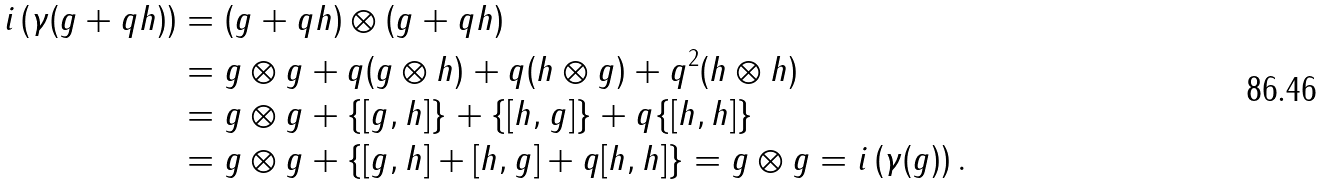Convert formula to latex. <formula><loc_0><loc_0><loc_500><loc_500>i \left ( \gamma ( g + q h ) \right ) & = ( g + q h ) \otimes ( g + q h ) \\ & = g \otimes g + q ( g \otimes h ) + q ( h \otimes g ) + q ^ { 2 } ( h \otimes h ) \\ & = g \otimes g + \{ [ g , h ] \} + \{ [ h , g ] \} + q \{ [ h , h ] \} \\ & = g \otimes g + \{ [ g , h ] + [ h , g ] + q [ h , h ] \} = g \otimes g = i \left ( \gamma ( g ) \right ) .</formula> 